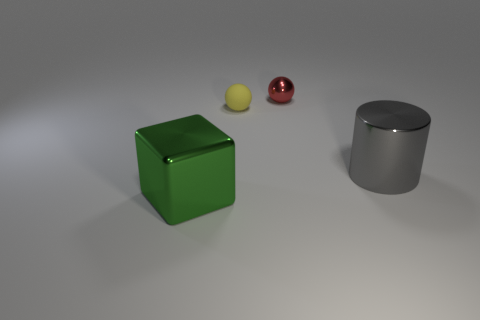Add 1 big brown things. How many objects exist? 5 Subtract all cubes. How many objects are left? 3 Add 4 tiny objects. How many tiny objects are left? 6 Add 4 big metal blocks. How many big metal blocks exist? 5 Subtract 0 purple balls. How many objects are left? 4 Subtract all purple matte cylinders. Subtract all spheres. How many objects are left? 2 